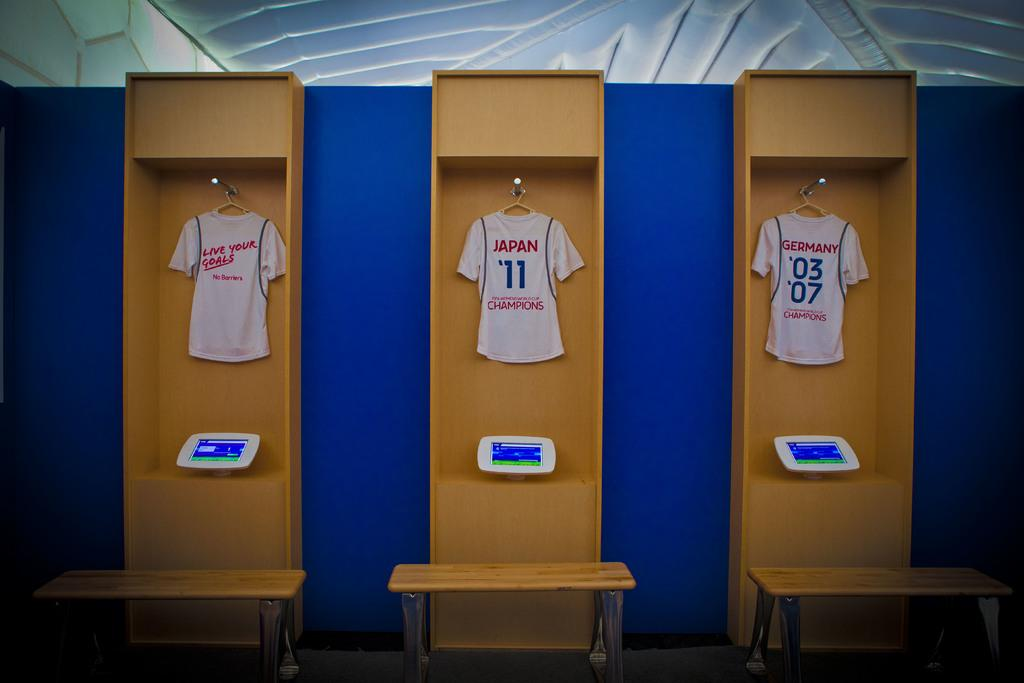<image>
Summarize the visual content of the image. One of the three shirts has the word Japan on it 